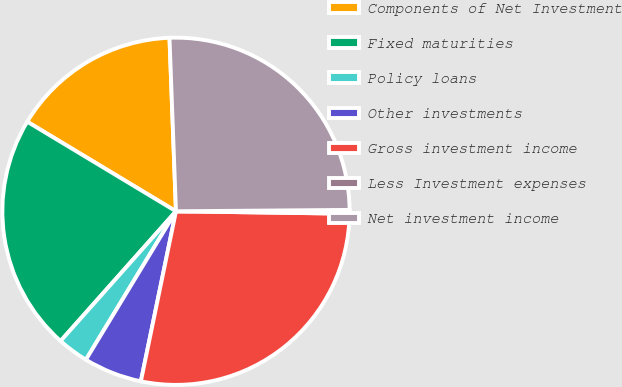Convert chart to OTSL. <chart><loc_0><loc_0><loc_500><loc_500><pie_chart><fcel>Components of Net Investment<fcel>Fixed maturities<fcel>Policy loans<fcel>Other investments<fcel>Gross investment income<fcel>Less Investment expenses<fcel>Net investment income<nl><fcel>15.78%<fcel>22.06%<fcel>2.89%<fcel>5.44%<fcel>28.02%<fcel>0.35%<fcel>25.47%<nl></chart> 